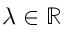Convert formula to latex. <formula><loc_0><loc_0><loc_500><loc_500>\lambda \in \mathbb { R }</formula> 